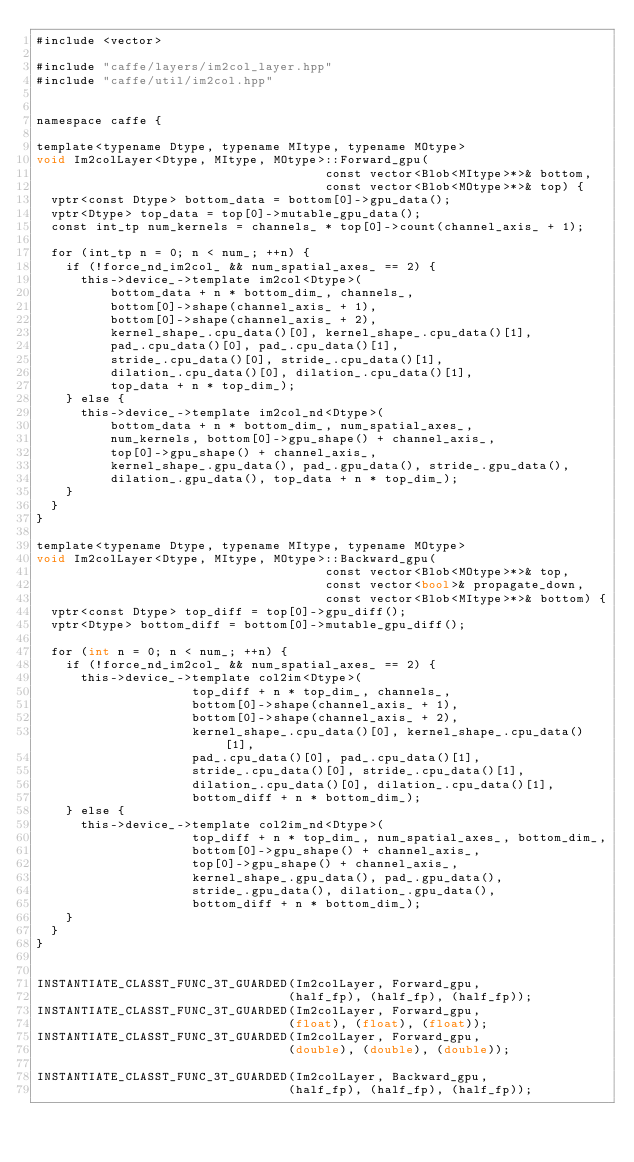<code> <loc_0><loc_0><loc_500><loc_500><_Cuda_>#include <vector>

#include "caffe/layers/im2col_layer.hpp"
#include "caffe/util/im2col.hpp"


namespace caffe {

template<typename Dtype, typename MItype, typename MOtype>
void Im2colLayer<Dtype, MItype, MOtype>::Forward_gpu(
                                       const vector<Blob<MItype>*>& bottom,
                                       const vector<Blob<MOtype>*>& top) {
  vptr<const Dtype> bottom_data = bottom[0]->gpu_data();
  vptr<Dtype> top_data = top[0]->mutable_gpu_data();
  const int_tp num_kernels = channels_ * top[0]->count(channel_axis_ + 1);

  for (int_tp n = 0; n < num_; ++n) {
    if (!force_nd_im2col_ && num_spatial_axes_ == 2) {
      this->device_->template im2col<Dtype>(
          bottom_data + n * bottom_dim_, channels_,
          bottom[0]->shape(channel_axis_ + 1),
          bottom[0]->shape(channel_axis_ + 2),
          kernel_shape_.cpu_data()[0], kernel_shape_.cpu_data()[1],
          pad_.cpu_data()[0], pad_.cpu_data()[1],
          stride_.cpu_data()[0], stride_.cpu_data()[1],
          dilation_.cpu_data()[0], dilation_.cpu_data()[1],
          top_data + n * top_dim_);
    } else {
      this->device_->template im2col_nd<Dtype>(
          bottom_data + n * bottom_dim_, num_spatial_axes_,
          num_kernels, bottom[0]->gpu_shape() + channel_axis_,
          top[0]->gpu_shape() + channel_axis_,
          kernel_shape_.gpu_data(), pad_.gpu_data(), stride_.gpu_data(),
          dilation_.gpu_data(), top_data + n * top_dim_);
    }
  }
}

template<typename Dtype, typename MItype, typename MOtype>
void Im2colLayer<Dtype, MItype, MOtype>::Backward_gpu(
                                       const vector<Blob<MOtype>*>& top,
                                       const vector<bool>& propagate_down,
                                       const vector<Blob<MItype>*>& bottom) {
  vptr<const Dtype> top_diff = top[0]->gpu_diff();
  vptr<Dtype> bottom_diff = bottom[0]->mutable_gpu_diff();

  for (int n = 0; n < num_; ++n) {
    if (!force_nd_im2col_ && num_spatial_axes_ == 2) {
      this->device_->template col2im<Dtype>(
                     top_diff + n * top_dim_, channels_,
                     bottom[0]->shape(channel_axis_ + 1),
                     bottom[0]->shape(channel_axis_ + 2),
                     kernel_shape_.cpu_data()[0], kernel_shape_.cpu_data()[1],
                     pad_.cpu_data()[0], pad_.cpu_data()[1],
                     stride_.cpu_data()[0], stride_.cpu_data()[1],
                     dilation_.cpu_data()[0], dilation_.cpu_data()[1],
                     bottom_diff + n * bottom_dim_);
    } else {
      this->device_->template col2im_nd<Dtype>(
                     top_diff + n * top_dim_, num_spatial_axes_, bottom_dim_,
                     bottom[0]->gpu_shape() + channel_axis_,
                     top[0]->gpu_shape() + channel_axis_,
                     kernel_shape_.gpu_data(), pad_.gpu_data(),
                     stride_.gpu_data(), dilation_.gpu_data(),
                     bottom_diff + n * bottom_dim_);
    }
  }
}


INSTANTIATE_CLASST_FUNC_3T_GUARDED(Im2colLayer, Forward_gpu,
                                  (half_fp), (half_fp), (half_fp));
INSTANTIATE_CLASST_FUNC_3T_GUARDED(Im2colLayer, Forward_gpu,
                                  (float), (float), (float));
INSTANTIATE_CLASST_FUNC_3T_GUARDED(Im2colLayer, Forward_gpu,
                                  (double), (double), (double));

INSTANTIATE_CLASST_FUNC_3T_GUARDED(Im2colLayer, Backward_gpu,
                                  (half_fp), (half_fp), (half_fp));</code> 